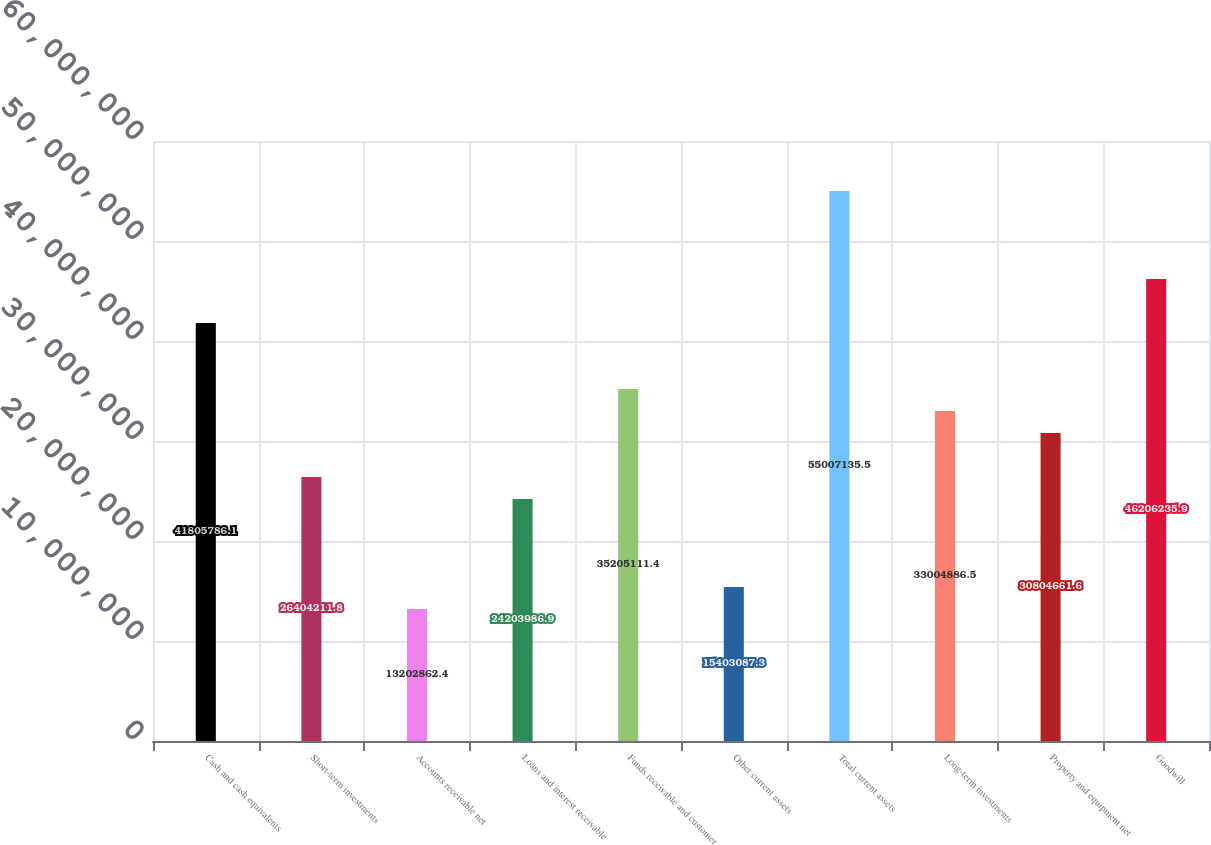<chart> <loc_0><loc_0><loc_500><loc_500><bar_chart><fcel>Cash and cash equivalents<fcel>Short-term investments<fcel>Accounts receivable net<fcel>Loans and interest receivable<fcel>Funds receivable and customer<fcel>Other current assets<fcel>Total current assets<fcel>Long-term investments<fcel>Property and equipment net<fcel>Goodwill<nl><fcel>4.18058e+07<fcel>2.64042e+07<fcel>1.32029e+07<fcel>2.4204e+07<fcel>3.52051e+07<fcel>1.54031e+07<fcel>5.50071e+07<fcel>3.30049e+07<fcel>3.08047e+07<fcel>4.62062e+07<nl></chart> 